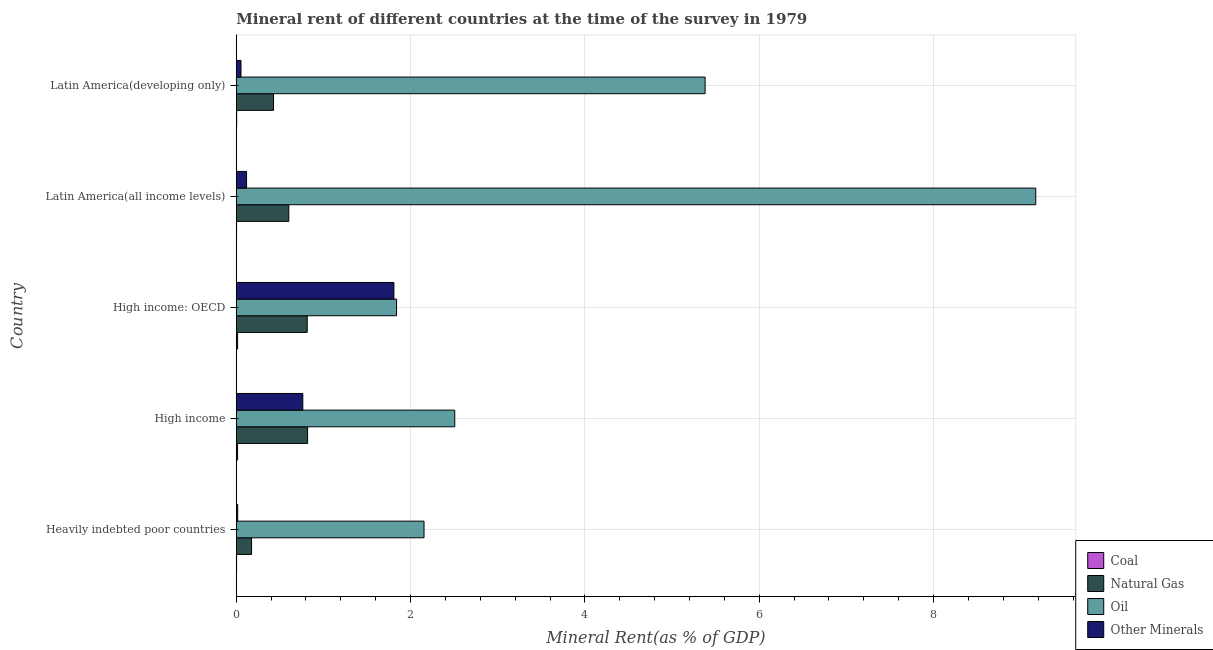How many bars are there on the 3rd tick from the top?
Give a very brief answer. 4. What is the label of the 5th group of bars from the top?
Ensure brevity in your answer.  Heavily indebted poor countries. In how many cases, is the number of bars for a given country not equal to the number of legend labels?
Your response must be concise. 0. What is the  rent of other minerals in Latin America(all income levels)?
Give a very brief answer. 0.12. Across all countries, what is the maximum oil rent?
Provide a short and direct response. 9.17. Across all countries, what is the minimum  rent of other minerals?
Your response must be concise. 0.02. In which country was the  rent of other minerals maximum?
Provide a succinct answer. High income: OECD. In which country was the natural gas rent minimum?
Your answer should be compact. Heavily indebted poor countries. What is the total natural gas rent in the graph?
Keep it short and to the point. 2.84. What is the difference between the natural gas rent in High income and that in Latin America(developing only)?
Ensure brevity in your answer.  0.39. What is the difference between the natural gas rent in High income and the  rent of other minerals in Heavily indebted poor countries?
Your response must be concise. 0.8. What is the average  rent of other minerals per country?
Your answer should be compact. 0.55. What is the difference between the natural gas rent and oil rent in Latin America(all income levels)?
Offer a terse response. -8.57. What is the ratio of the natural gas rent in Heavily indebted poor countries to that in Latin America(all income levels)?
Ensure brevity in your answer.  0.29. What is the difference between the highest and the second highest coal rent?
Make the answer very short. 0. What is the difference between the highest and the lowest natural gas rent?
Make the answer very short. 0.64. Is the sum of the  rent of other minerals in Latin America(all income levels) and Latin America(developing only) greater than the maximum oil rent across all countries?
Your answer should be very brief. No. Is it the case that in every country, the sum of the coal rent and  rent of other minerals is greater than the sum of natural gas rent and oil rent?
Ensure brevity in your answer.  No. What does the 2nd bar from the top in Latin America(all income levels) represents?
Provide a succinct answer. Oil. What does the 2nd bar from the bottom in Heavily indebted poor countries represents?
Your answer should be very brief. Natural Gas. Are all the bars in the graph horizontal?
Provide a short and direct response. Yes. How many countries are there in the graph?
Give a very brief answer. 5. What is the difference between two consecutive major ticks on the X-axis?
Your response must be concise. 2. Are the values on the major ticks of X-axis written in scientific E-notation?
Your answer should be compact. No. Does the graph contain grids?
Offer a very short reply. Yes. Where does the legend appear in the graph?
Provide a short and direct response. Bottom right. What is the title of the graph?
Your response must be concise. Mineral rent of different countries at the time of the survey in 1979. Does "Grants and Revenue" appear as one of the legend labels in the graph?
Keep it short and to the point. No. What is the label or title of the X-axis?
Ensure brevity in your answer.  Mineral Rent(as % of GDP). What is the label or title of the Y-axis?
Your answer should be very brief. Country. What is the Mineral Rent(as % of GDP) in Coal in Heavily indebted poor countries?
Provide a short and direct response. 0. What is the Mineral Rent(as % of GDP) in Natural Gas in Heavily indebted poor countries?
Make the answer very short. 0.18. What is the Mineral Rent(as % of GDP) in Oil in Heavily indebted poor countries?
Offer a terse response. 2.15. What is the Mineral Rent(as % of GDP) in Other Minerals in Heavily indebted poor countries?
Give a very brief answer. 0.02. What is the Mineral Rent(as % of GDP) of Coal in High income?
Ensure brevity in your answer.  0.02. What is the Mineral Rent(as % of GDP) in Natural Gas in High income?
Provide a short and direct response. 0.82. What is the Mineral Rent(as % of GDP) of Oil in High income?
Offer a terse response. 2.51. What is the Mineral Rent(as % of GDP) of Other Minerals in High income?
Provide a short and direct response. 0.76. What is the Mineral Rent(as % of GDP) in Coal in High income: OECD?
Give a very brief answer. 0.02. What is the Mineral Rent(as % of GDP) in Natural Gas in High income: OECD?
Offer a very short reply. 0.81. What is the Mineral Rent(as % of GDP) in Oil in High income: OECD?
Keep it short and to the point. 1.84. What is the Mineral Rent(as % of GDP) of Other Minerals in High income: OECD?
Provide a succinct answer. 1.81. What is the Mineral Rent(as % of GDP) in Coal in Latin America(all income levels)?
Offer a terse response. 0. What is the Mineral Rent(as % of GDP) in Natural Gas in Latin America(all income levels)?
Make the answer very short. 0.6. What is the Mineral Rent(as % of GDP) of Oil in Latin America(all income levels)?
Keep it short and to the point. 9.17. What is the Mineral Rent(as % of GDP) of Other Minerals in Latin America(all income levels)?
Make the answer very short. 0.12. What is the Mineral Rent(as % of GDP) of Coal in Latin America(developing only)?
Provide a short and direct response. 0. What is the Mineral Rent(as % of GDP) in Natural Gas in Latin America(developing only)?
Give a very brief answer. 0.43. What is the Mineral Rent(as % of GDP) in Oil in Latin America(developing only)?
Your response must be concise. 5.38. What is the Mineral Rent(as % of GDP) of Other Minerals in Latin America(developing only)?
Make the answer very short. 0.05. Across all countries, what is the maximum Mineral Rent(as % of GDP) of Coal?
Your response must be concise. 0.02. Across all countries, what is the maximum Mineral Rent(as % of GDP) of Natural Gas?
Provide a succinct answer. 0.82. Across all countries, what is the maximum Mineral Rent(as % of GDP) of Oil?
Ensure brevity in your answer.  9.17. Across all countries, what is the maximum Mineral Rent(as % of GDP) of Other Minerals?
Your answer should be compact. 1.81. Across all countries, what is the minimum Mineral Rent(as % of GDP) of Coal?
Ensure brevity in your answer.  0. Across all countries, what is the minimum Mineral Rent(as % of GDP) in Natural Gas?
Your response must be concise. 0.18. Across all countries, what is the minimum Mineral Rent(as % of GDP) in Oil?
Make the answer very short. 1.84. Across all countries, what is the minimum Mineral Rent(as % of GDP) in Other Minerals?
Ensure brevity in your answer.  0.02. What is the total Mineral Rent(as % of GDP) in Coal in the graph?
Your response must be concise. 0.04. What is the total Mineral Rent(as % of GDP) of Natural Gas in the graph?
Provide a short and direct response. 2.84. What is the total Mineral Rent(as % of GDP) in Oil in the graph?
Offer a very short reply. 21.05. What is the total Mineral Rent(as % of GDP) in Other Minerals in the graph?
Offer a very short reply. 2.76. What is the difference between the Mineral Rent(as % of GDP) in Coal in Heavily indebted poor countries and that in High income?
Your answer should be very brief. -0.01. What is the difference between the Mineral Rent(as % of GDP) in Natural Gas in Heavily indebted poor countries and that in High income?
Your response must be concise. -0.64. What is the difference between the Mineral Rent(as % of GDP) in Oil in Heavily indebted poor countries and that in High income?
Keep it short and to the point. -0.35. What is the difference between the Mineral Rent(as % of GDP) in Other Minerals in Heavily indebted poor countries and that in High income?
Your answer should be compact. -0.75. What is the difference between the Mineral Rent(as % of GDP) in Coal in Heavily indebted poor countries and that in High income: OECD?
Keep it short and to the point. -0.01. What is the difference between the Mineral Rent(as % of GDP) in Natural Gas in Heavily indebted poor countries and that in High income: OECD?
Offer a very short reply. -0.64. What is the difference between the Mineral Rent(as % of GDP) of Oil in Heavily indebted poor countries and that in High income: OECD?
Give a very brief answer. 0.31. What is the difference between the Mineral Rent(as % of GDP) in Other Minerals in Heavily indebted poor countries and that in High income: OECD?
Keep it short and to the point. -1.79. What is the difference between the Mineral Rent(as % of GDP) in Coal in Heavily indebted poor countries and that in Latin America(all income levels)?
Your answer should be very brief. 0. What is the difference between the Mineral Rent(as % of GDP) in Natural Gas in Heavily indebted poor countries and that in Latin America(all income levels)?
Your answer should be compact. -0.43. What is the difference between the Mineral Rent(as % of GDP) of Oil in Heavily indebted poor countries and that in Latin America(all income levels)?
Keep it short and to the point. -7.02. What is the difference between the Mineral Rent(as % of GDP) of Other Minerals in Heavily indebted poor countries and that in Latin America(all income levels)?
Provide a succinct answer. -0.1. What is the difference between the Mineral Rent(as % of GDP) in Coal in Heavily indebted poor countries and that in Latin America(developing only)?
Provide a succinct answer. -0. What is the difference between the Mineral Rent(as % of GDP) in Natural Gas in Heavily indebted poor countries and that in Latin America(developing only)?
Your response must be concise. -0.25. What is the difference between the Mineral Rent(as % of GDP) of Oil in Heavily indebted poor countries and that in Latin America(developing only)?
Ensure brevity in your answer.  -3.22. What is the difference between the Mineral Rent(as % of GDP) in Other Minerals in Heavily indebted poor countries and that in Latin America(developing only)?
Keep it short and to the point. -0.04. What is the difference between the Mineral Rent(as % of GDP) in Coal in High income and that in High income: OECD?
Provide a short and direct response. -0. What is the difference between the Mineral Rent(as % of GDP) of Natural Gas in High income and that in High income: OECD?
Your response must be concise. 0. What is the difference between the Mineral Rent(as % of GDP) in Oil in High income and that in High income: OECD?
Make the answer very short. 0.67. What is the difference between the Mineral Rent(as % of GDP) of Other Minerals in High income and that in High income: OECD?
Provide a succinct answer. -1.05. What is the difference between the Mineral Rent(as % of GDP) of Coal in High income and that in Latin America(all income levels)?
Give a very brief answer. 0.01. What is the difference between the Mineral Rent(as % of GDP) of Natural Gas in High income and that in Latin America(all income levels)?
Keep it short and to the point. 0.22. What is the difference between the Mineral Rent(as % of GDP) of Oil in High income and that in Latin America(all income levels)?
Your answer should be very brief. -6.67. What is the difference between the Mineral Rent(as % of GDP) of Other Minerals in High income and that in Latin America(all income levels)?
Provide a short and direct response. 0.65. What is the difference between the Mineral Rent(as % of GDP) of Coal in High income and that in Latin America(developing only)?
Offer a terse response. 0.01. What is the difference between the Mineral Rent(as % of GDP) of Natural Gas in High income and that in Latin America(developing only)?
Your response must be concise. 0.39. What is the difference between the Mineral Rent(as % of GDP) in Oil in High income and that in Latin America(developing only)?
Your answer should be very brief. -2.87. What is the difference between the Mineral Rent(as % of GDP) in Other Minerals in High income and that in Latin America(developing only)?
Provide a short and direct response. 0.71. What is the difference between the Mineral Rent(as % of GDP) in Coal in High income: OECD and that in Latin America(all income levels)?
Offer a very short reply. 0.01. What is the difference between the Mineral Rent(as % of GDP) of Natural Gas in High income: OECD and that in Latin America(all income levels)?
Make the answer very short. 0.21. What is the difference between the Mineral Rent(as % of GDP) of Oil in High income: OECD and that in Latin America(all income levels)?
Your response must be concise. -7.33. What is the difference between the Mineral Rent(as % of GDP) in Other Minerals in High income: OECD and that in Latin America(all income levels)?
Your answer should be compact. 1.69. What is the difference between the Mineral Rent(as % of GDP) in Coal in High income: OECD and that in Latin America(developing only)?
Ensure brevity in your answer.  0.01. What is the difference between the Mineral Rent(as % of GDP) in Natural Gas in High income: OECD and that in Latin America(developing only)?
Make the answer very short. 0.39. What is the difference between the Mineral Rent(as % of GDP) in Oil in High income: OECD and that in Latin America(developing only)?
Your answer should be very brief. -3.54. What is the difference between the Mineral Rent(as % of GDP) in Other Minerals in High income: OECD and that in Latin America(developing only)?
Give a very brief answer. 1.75. What is the difference between the Mineral Rent(as % of GDP) in Coal in Latin America(all income levels) and that in Latin America(developing only)?
Keep it short and to the point. -0. What is the difference between the Mineral Rent(as % of GDP) of Natural Gas in Latin America(all income levels) and that in Latin America(developing only)?
Ensure brevity in your answer.  0.18. What is the difference between the Mineral Rent(as % of GDP) of Oil in Latin America(all income levels) and that in Latin America(developing only)?
Offer a terse response. 3.79. What is the difference between the Mineral Rent(as % of GDP) of Other Minerals in Latin America(all income levels) and that in Latin America(developing only)?
Keep it short and to the point. 0.06. What is the difference between the Mineral Rent(as % of GDP) in Coal in Heavily indebted poor countries and the Mineral Rent(as % of GDP) in Natural Gas in High income?
Provide a short and direct response. -0.81. What is the difference between the Mineral Rent(as % of GDP) in Coal in Heavily indebted poor countries and the Mineral Rent(as % of GDP) in Oil in High income?
Your answer should be very brief. -2.5. What is the difference between the Mineral Rent(as % of GDP) in Coal in Heavily indebted poor countries and the Mineral Rent(as % of GDP) in Other Minerals in High income?
Provide a short and direct response. -0.76. What is the difference between the Mineral Rent(as % of GDP) of Natural Gas in Heavily indebted poor countries and the Mineral Rent(as % of GDP) of Oil in High income?
Ensure brevity in your answer.  -2.33. What is the difference between the Mineral Rent(as % of GDP) in Natural Gas in Heavily indebted poor countries and the Mineral Rent(as % of GDP) in Other Minerals in High income?
Offer a very short reply. -0.59. What is the difference between the Mineral Rent(as % of GDP) in Oil in Heavily indebted poor countries and the Mineral Rent(as % of GDP) in Other Minerals in High income?
Ensure brevity in your answer.  1.39. What is the difference between the Mineral Rent(as % of GDP) of Coal in Heavily indebted poor countries and the Mineral Rent(as % of GDP) of Natural Gas in High income: OECD?
Give a very brief answer. -0.81. What is the difference between the Mineral Rent(as % of GDP) in Coal in Heavily indebted poor countries and the Mineral Rent(as % of GDP) in Oil in High income: OECD?
Make the answer very short. -1.84. What is the difference between the Mineral Rent(as % of GDP) in Coal in Heavily indebted poor countries and the Mineral Rent(as % of GDP) in Other Minerals in High income: OECD?
Offer a very short reply. -1.81. What is the difference between the Mineral Rent(as % of GDP) of Natural Gas in Heavily indebted poor countries and the Mineral Rent(as % of GDP) of Oil in High income: OECD?
Your answer should be very brief. -1.66. What is the difference between the Mineral Rent(as % of GDP) in Natural Gas in Heavily indebted poor countries and the Mineral Rent(as % of GDP) in Other Minerals in High income: OECD?
Provide a short and direct response. -1.63. What is the difference between the Mineral Rent(as % of GDP) of Oil in Heavily indebted poor countries and the Mineral Rent(as % of GDP) of Other Minerals in High income: OECD?
Offer a very short reply. 0.35. What is the difference between the Mineral Rent(as % of GDP) of Coal in Heavily indebted poor countries and the Mineral Rent(as % of GDP) of Natural Gas in Latin America(all income levels)?
Offer a terse response. -0.6. What is the difference between the Mineral Rent(as % of GDP) of Coal in Heavily indebted poor countries and the Mineral Rent(as % of GDP) of Oil in Latin America(all income levels)?
Make the answer very short. -9.17. What is the difference between the Mineral Rent(as % of GDP) of Coal in Heavily indebted poor countries and the Mineral Rent(as % of GDP) of Other Minerals in Latin America(all income levels)?
Ensure brevity in your answer.  -0.11. What is the difference between the Mineral Rent(as % of GDP) of Natural Gas in Heavily indebted poor countries and the Mineral Rent(as % of GDP) of Oil in Latin America(all income levels)?
Ensure brevity in your answer.  -9. What is the difference between the Mineral Rent(as % of GDP) in Natural Gas in Heavily indebted poor countries and the Mineral Rent(as % of GDP) in Other Minerals in Latin America(all income levels)?
Offer a very short reply. 0.06. What is the difference between the Mineral Rent(as % of GDP) in Oil in Heavily indebted poor countries and the Mineral Rent(as % of GDP) in Other Minerals in Latin America(all income levels)?
Your answer should be compact. 2.04. What is the difference between the Mineral Rent(as % of GDP) of Coal in Heavily indebted poor countries and the Mineral Rent(as % of GDP) of Natural Gas in Latin America(developing only)?
Ensure brevity in your answer.  -0.42. What is the difference between the Mineral Rent(as % of GDP) of Coal in Heavily indebted poor countries and the Mineral Rent(as % of GDP) of Oil in Latin America(developing only)?
Give a very brief answer. -5.38. What is the difference between the Mineral Rent(as % of GDP) of Coal in Heavily indebted poor countries and the Mineral Rent(as % of GDP) of Other Minerals in Latin America(developing only)?
Provide a short and direct response. -0.05. What is the difference between the Mineral Rent(as % of GDP) of Natural Gas in Heavily indebted poor countries and the Mineral Rent(as % of GDP) of Oil in Latin America(developing only)?
Provide a short and direct response. -5.2. What is the difference between the Mineral Rent(as % of GDP) in Natural Gas in Heavily indebted poor countries and the Mineral Rent(as % of GDP) in Other Minerals in Latin America(developing only)?
Offer a terse response. 0.12. What is the difference between the Mineral Rent(as % of GDP) in Coal in High income and the Mineral Rent(as % of GDP) in Natural Gas in High income: OECD?
Provide a succinct answer. -0.8. What is the difference between the Mineral Rent(as % of GDP) of Coal in High income and the Mineral Rent(as % of GDP) of Oil in High income: OECD?
Provide a short and direct response. -1.82. What is the difference between the Mineral Rent(as % of GDP) of Coal in High income and the Mineral Rent(as % of GDP) of Other Minerals in High income: OECD?
Provide a succinct answer. -1.79. What is the difference between the Mineral Rent(as % of GDP) in Natural Gas in High income and the Mineral Rent(as % of GDP) in Oil in High income: OECD?
Offer a very short reply. -1.02. What is the difference between the Mineral Rent(as % of GDP) in Natural Gas in High income and the Mineral Rent(as % of GDP) in Other Minerals in High income: OECD?
Provide a succinct answer. -0.99. What is the difference between the Mineral Rent(as % of GDP) of Oil in High income and the Mineral Rent(as % of GDP) of Other Minerals in High income: OECD?
Make the answer very short. 0.7. What is the difference between the Mineral Rent(as % of GDP) in Coal in High income and the Mineral Rent(as % of GDP) in Natural Gas in Latin America(all income levels)?
Make the answer very short. -0.59. What is the difference between the Mineral Rent(as % of GDP) in Coal in High income and the Mineral Rent(as % of GDP) in Oil in Latin America(all income levels)?
Keep it short and to the point. -9.16. What is the difference between the Mineral Rent(as % of GDP) in Coal in High income and the Mineral Rent(as % of GDP) in Other Minerals in Latin America(all income levels)?
Offer a very short reply. -0.1. What is the difference between the Mineral Rent(as % of GDP) of Natural Gas in High income and the Mineral Rent(as % of GDP) of Oil in Latin America(all income levels)?
Keep it short and to the point. -8.35. What is the difference between the Mineral Rent(as % of GDP) of Natural Gas in High income and the Mineral Rent(as % of GDP) of Other Minerals in Latin America(all income levels)?
Offer a very short reply. 0.7. What is the difference between the Mineral Rent(as % of GDP) of Oil in High income and the Mineral Rent(as % of GDP) of Other Minerals in Latin America(all income levels)?
Ensure brevity in your answer.  2.39. What is the difference between the Mineral Rent(as % of GDP) of Coal in High income and the Mineral Rent(as % of GDP) of Natural Gas in Latin America(developing only)?
Provide a succinct answer. -0.41. What is the difference between the Mineral Rent(as % of GDP) in Coal in High income and the Mineral Rent(as % of GDP) in Oil in Latin America(developing only)?
Give a very brief answer. -5.36. What is the difference between the Mineral Rent(as % of GDP) of Coal in High income and the Mineral Rent(as % of GDP) of Other Minerals in Latin America(developing only)?
Provide a short and direct response. -0.04. What is the difference between the Mineral Rent(as % of GDP) in Natural Gas in High income and the Mineral Rent(as % of GDP) in Oil in Latin America(developing only)?
Offer a very short reply. -4.56. What is the difference between the Mineral Rent(as % of GDP) of Natural Gas in High income and the Mineral Rent(as % of GDP) of Other Minerals in Latin America(developing only)?
Your answer should be very brief. 0.76. What is the difference between the Mineral Rent(as % of GDP) of Oil in High income and the Mineral Rent(as % of GDP) of Other Minerals in Latin America(developing only)?
Your response must be concise. 2.45. What is the difference between the Mineral Rent(as % of GDP) in Coal in High income: OECD and the Mineral Rent(as % of GDP) in Natural Gas in Latin America(all income levels)?
Your answer should be very brief. -0.59. What is the difference between the Mineral Rent(as % of GDP) in Coal in High income: OECD and the Mineral Rent(as % of GDP) in Oil in Latin America(all income levels)?
Provide a succinct answer. -9.16. What is the difference between the Mineral Rent(as % of GDP) of Coal in High income: OECD and the Mineral Rent(as % of GDP) of Other Minerals in Latin America(all income levels)?
Offer a terse response. -0.1. What is the difference between the Mineral Rent(as % of GDP) in Natural Gas in High income: OECD and the Mineral Rent(as % of GDP) in Oil in Latin America(all income levels)?
Provide a short and direct response. -8.36. What is the difference between the Mineral Rent(as % of GDP) of Natural Gas in High income: OECD and the Mineral Rent(as % of GDP) of Other Minerals in Latin America(all income levels)?
Your response must be concise. 0.7. What is the difference between the Mineral Rent(as % of GDP) of Oil in High income: OECD and the Mineral Rent(as % of GDP) of Other Minerals in Latin America(all income levels)?
Your answer should be very brief. 1.72. What is the difference between the Mineral Rent(as % of GDP) of Coal in High income: OECD and the Mineral Rent(as % of GDP) of Natural Gas in Latin America(developing only)?
Give a very brief answer. -0.41. What is the difference between the Mineral Rent(as % of GDP) in Coal in High income: OECD and the Mineral Rent(as % of GDP) in Oil in Latin America(developing only)?
Your response must be concise. -5.36. What is the difference between the Mineral Rent(as % of GDP) of Coal in High income: OECD and the Mineral Rent(as % of GDP) of Other Minerals in Latin America(developing only)?
Your response must be concise. -0.04. What is the difference between the Mineral Rent(as % of GDP) of Natural Gas in High income: OECD and the Mineral Rent(as % of GDP) of Oil in Latin America(developing only)?
Your answer should be very brief. -4.56. What is the difference between the Mineral Rent(as % of GDP) in Natural Gas in High income: OECD and the Mineral Rent(as % of GDP) in Other Minerals in Latin America(developing only)?
Give a very brief answer. 0.76. What is the difference between the Mineral Rent(as % of GDP) of Oil in High income: OECD and the Mineral Rent(as % of GDP) of Other Minerals in Latin America(developing only)?
Provide a short and direct response. 1.79. What is the difference between the Mineral Rent(as % of GDP) of Coal in Latin America(all income levels) and the Mineral Rent(as % of GDP) of Natural Gas in Latin America(developing only)?
Your response must be concise. -0.42. What is the difference between the Mineral Rent(as % of GDP) of Coal in Latin America(all income levels) and the Mineral Rent(as % of GDP) of Oil in Latin America(developing only)?
Provide a short and direct response. -5.38. What is the difference between the Mineral Rent(as % of GDP) in Coal in Latin America(all income levels) and the Mineral Rent(as % of GDP) in Other Minerals in Latin America(developing only)?
Offer a terse response. -0.05. What is the difference between the Mineral Rent(as % of GDP) of Natural Gas in Latin America(all income levels) and the Mineral Rent(as % of GDP) of Oil in Latin America(developing only)?
Provide a succinct answer. -4.78. What is the difference between the Mineral Rent(as % of GDP) in Natural Gas in Latin America(all income levels) and the Mineral Rent(as % of GDP) in Other Minerals in Latin America(developing only)?
Provide a short and direct response. 0.55. What is the difference between the Mineral Rent(as % of GDP) of Oil in Latin America(all income levels) and the Mineral Rent(as % of GDP) of Other Minerals in Latin America(developing only)?
Provide a short and direct response. 9.12. What is the average Mineral Rent(as % of GDP) in Coal per country?
Provide a short and direct response. 0.01. What is the average Mineral Rent(as % of GDP) in Natural Gas per country?
Your answer should be very brief. 0.57. What is the average Mineral Rent(as % of GDP) in Oil per country?
Provide a short and direct response. 4.21. What is the average Mineral Rent(as % of GDP) of Other Minerals per country?
Keep it short and to the point. 0.55. What is the difference between the Mineral Rent(as % of GDP) in Coal and Mineral Rent(as % of GDP) in Natural Gas in Heavily indebted poor countries?
Give a very brief answer. -0.17. What is the difference between the Mineral Rent(as % of GDP) of Coal and Mineral Rent(as % of GDP) of Oil in Heavily indebted poor countries?
Offer a very short reply. -2.15. What is the difference between the Mineral Rent(as % of GDP) of Coal and Mineral Rent(as % of GDP) of Other Minerals in Heavily indebted poor countries?
Ensure brevity in your answer.  -0.01. What is the difference between the Mineral Rent(as % of GDP) of Natural Gas and Mineral Rent(as % of GDP) of Oil in Heavily indebted poor countries?
Offer a terse response. -1.98. What is the difference between the Mineral Rent(as % of GDP) of Natural Gas and Mineral Rent(as % of GDP) of Other Minerals in Heavily indebted poor countries?
Make the answer very short. 0.16. What is the difference between the Mineral Rent(as % of GDP) of Oil and Mineral Rent(as % of GDP) of Other Minerals in Heavily indebted poor countries?
Make the answer very short. 2.14. What is the difference between the Mineral Rent(as % of GDP) in Coal and Mineral Rent(as % of GDP) in Natural Gas in High income?
Your answer should be very brief. -0.8. What is the difference between the Mineral Rent(as % of GDP) of Coal and Mineral Rent(as % of GDP) of Oil in High income?
Give a very brief answer. -2.49. What is the difference between the Mineral Rent(as % of GDP) of Coal and Mineral Rent(as % of GDP) of Other Minerals in High income?
Your response must be concise. -0.75. What is the difference between the Mineral Rent(as % of GDP) of Natural Gas and Mineral Rent(as % of GDP) of Oil in High income?
Give a very brief answer. -1.69. What is the difference between the Mineral Rent(as % of GDP) of Natural Gas and Mineral Rent(as % of GDP) of Other Minerals in High income?
Give a very brief answer. 0.05. What is the difference between the Mineral Rent(as % of GDP) in Oil and Mineral Rent(as % of GDP) in Other Minerals in High income?
Your response must be concise. 1.74. What is the difference between the Mineral Rent(as % of GDP) of Coal and Mineral Rent(as % of GDP) of Natural Gas in High income: OECD?
Keep it short and to the point. -0.8. What is the difference between the Mineral Rent(as % of GDP) in Coal and Mineral Rent(as % of GDP) in Oil in High income: OECD?
Offer a very short reply. -1.82. What is the difference between the Mineral Rent(as % of GDP) in Coal and Mineral Rent(as % of GDP) in Other Minerals in High income: OECD?
Your answer should be very brief. -1.79. What is the difference between the Mineral Rent(as % of GDP) of Natural Gas and Mineral Rent(as % of GDP) of Oil in High income: OECD?
Offer a terse response. -1.03. What is the difference between the Mineral Rent(as % of GDP) of Natural Gas and Mineral Rent(as % of GDP) of Other Minerals in High income: OECD?
Make the answer very short. -0.99. What is the difference between the Mineral Rent(as % of GDP) in Oil and Mineral Rent(as % of GDP) in Other Minerals in High income: OECD?
Make the answer very short. 0.03. What is the difference between the Mineral Rent(as % of GDP) in Coal and Mineral Rent(as % of GDP) in Natural Gas in Latin America(all income levels)?
Ensure brevity in your answer.  -0.6. What is the difference between the Mineral Rent(as % of GDP) of Coal and Mineral Rent(as % of GDP) of Oil in Latin America(all income levels)?
Offer a very short reply. -9.17. What is the difference between the Mineral Rent(as % of GDP) of Coal and Mineral Rent(as % of GDP) of Other Minerals in Latin America(all income levels)?
Your answer should be compact. -0.11. What is the difference between the Mineral Rent(as % of GDP) of Natural Gas and Mineral Rent(as % of GDP) of Oil in Latin America(all income levels)?
Your response must be concise. -8.57. What is the difference between the Mineral Rent(as % of GDP) in Natural Gas and Mineral Rent(as % of GDP) in Other Minerals in Latin America(all income levels)?
Provide a succinct answer. 0.48. What is the difference between the Mineral Rent(as % of GDP) of Oil and Mineral Rent(as % of GDP) of Other Minerals in Latin America(all income levels)?
Make the answer very short. 9.05. What is the difference between the Mineral Rent(as % of GDP) of Coal and Mineral Rent(as % of GDP) of Natural Gas in Latin America(developing only)?
Give a very brief answer. -0.42. What is the difference between the Mineral Rent(as % of GDP) of Coal and Mineral Rent(as % of GDP) of Oil in Latin America(developing only)?
Provide a short and direct response. -5.37. What is the difference between the Mineral Rent(as % of GDP) of Coal and Mineral Rent(as % of GDP) of Other Minerals in Latin America(developing only)?
Your answer should be compact. -0.05. What is the difference between the Mineral Rent(as % of GDP) of Natural Gas and Mineral Rent(as % of GDP) of Oil in Latin America(developing only)?
Offer a very short reply. -4.95. What is the difference between the Mineral Rent(as % of GDP) in Natural Gas and Mineral Rent(as % of GDP) in Other Minerals in Latin America(developing only)?
Provide a short and direct response. 0.37. What is the difference between the Mineral Rent(as % of GDP) of Oil and Mineral Rent(as % of GDP) of Other Minerals in Latin America(developing only)?
Keep it short and to the point. 5.32. What is the ratio of the Mineral Rent(as % of GDP) of Coal in Heavily indebted poor countries to that in High income?
Give a very brief answer. 0.24. What is the ratio of the Mineral Rent(as % of GDP) of Natural Gas in Heavily indebted poor countries to that in High income?
Provide a succinct answer. 0.21. What is the ratio of the Mineral Rent(as % of GDP) in Oil in Heavily indebted poor countries to that in High income?
Your response must be concise. 0.86. What is the ratio of the Mineral Rent(as % of GDP) in Other Minerals in Heavily indebted poor countries to that in High income?
Give a very brief answer. 0.02. What is the ratio of the Mineral Rent(as % of GDP) of Coal in Heavily indebted poor countries to that in High income: OECD?
Provide a succinct answer. 0.24. What is the ratio of the Mineral Rent(as % of GDP) in Natural Gas in Heavily indebted poor countries to that in High income: OECD?
Your response must be concise. 0.22. What is the ratio of the Mineral Rent(as % of GDP) of Oil in Heavily indebted poor countries to that in High income: OECD?
Make the answer very short. 1.17. What is the ratio of the Mineral Rent(as % of GDP) in Other Minerals in Heavily indebted poor countries to that in High income: OECD?
Provide a succinct answer. 0.01. What is the ratio of the Mineral Rent(as % of GDP) in Coal in Heavily indebted poor countries to that in Latin America(all income levels)?
Offer a very short reply. 1.04. What is the ratio of the Mineral Rent(as % of GDP) of Natural Gas in Heavily indebted poor countries to that in Latin America(all income levels)?
Keep it short and to the point. 0.29. What is the ratio of the Mineral Rent(as % of GDP) in Oil in Heavily indebted poor countries to that in Latin America(all income levels)?
Your answer should be compact. 0.23. What is the ratio of the Mineral Rent(as % of GDP) of Other Minerals in Heavily indebted poor countries to that in Latin America(all income levels)?
Give a very brief answer. 0.14. What is the ratio of the Mineral Rent(as % of GDP) of Coal in Heavily indebted poor countries to that in Latin America(developing only)?
Offer a very short reply. 0.77. What is the ratio of the Mineral Rent(as % of GDP) of Natural Gas in Heavily indebted poor countries to that in Latin America(developing only)?
Make the answer very short. 0.41. What is the ratio of the Mineral Rent(as % of GDP) of Oil in Heavily indebted poor countries to that in Latin America(developing only)?
Provide a succinct answer. 0.4. What is the ratio of the Mineral Rent(as % of GDP) of Other Minerals in Heavily indebted poor countries to that in Latin America(developing only)?
Offer a very short reply. 0.3. What is the ratio of the Mineral Rent(as % of GDP) in Coal in High income to that in High income: OECD?
Provide a succinct answer. 0.98. What is the ratio of the Mineral Rent(as % of GDP) of Natural Gas in High income to that in High income: OECD?
Give a very brief answer. 1.01. What is the ratio of the Mineral Rent(as % of GDP) in Oil in High income to that in High income: OECD?
Keep it short and to the point. 1.36. What is the ratio of the Mineral Rent(as % of GDP) in Other Minerals in High income to that in High income: OECD?
Ensure brevity in your answer.  0.42. What is the ratio of the Mineral Rent(as % of GDP) in Coal in High income to that in Latin America(all income levels)?
Give a very brief answer. 4.3. What is the ratio of the Mineral Rent(as % of GDP) of Natural Gas in High income to that in Latin America(all income levels)?
Offer a very short reply. 1.36. What is the ratio of the Mineral Rent(as % of GDP) of Oil in High income to that in Latin America(all income levels)?
Offer a terse response. 0.27. What is the ratio of the Mineral Rent(as % of GDP) of Other Minerals in High income to that in Latin America(all income levels)?
Your answer should be very brief. 6.46. What is the ratio of the Mineral Rent(as % of GDP) of Coal in High income to that in Latin America(developing only)?
Provide a short and direct response. 3.16. What is the ratio of the Mineral Rent(as % of GDP) in Natural Gas in High income to that in Latin America(developing only)?
Your answer should be very brief. 1.91. What is the ratio of the Mineral Rent(as % of GDP) in Oil in High income to that in Latin America(developing only)?
Provide a short and direct response. 0.47. What is the ratio of the Mineral Rent(as % of GDP) of Other Minerals in High income to that in Latin America(developing only)?
Your answer should be compact. 14.06. What is the ratio of the Mineral Rent(as % of GDP) in Coal in High income: OECD to that in Latin America(all income levels)?
Offer a terse response. 4.4. What is the ratio of the Mineral Rent(as % of GDP) in Natural Gas in High income: OECD to that in Latin America(all income levels)?
Your answer should be compact. 1.35. What is the ratio of the Mineral Rent(as % of GDP) in Oil in High income: OECD to that in Latin America(all income levels)?
Make the answer very short. 0.2. What is the ratio of the Mineral Rent(as % of GDP) of Other Minerals in High income: OECD to that in Latin America(all income levels)?
Ensure brevity in your answer.  15.29. What is the ratio of the Mineral Rent(as % of GDP) of Coal in High income: OECD to that in Latin America(developing only)?
Provide a short and direct response. 3.23. What is the ratio of the Mineral Rent(as % of GDP) in Natural Gas in High income: OECD to that in Latin America(developing only)?
Offer a very short reply. 1.9. What is the ratio of the Mineral Rent(as % of GDP) of Oil in High income: OECD to that in Latin America(developing only)?
Give a very brief answer. 0.34. What is the ratio of the Mineral Rent(as % of GDP) of Other Minerals in High income: OECD to that in Latin America(developing only)?
Your answer should be very brief. 33.31. What is the ratio of the Mineral Rent(as % of GDP) in Coal in Latin America(all income levels) to that in Latin America(developing only)?
Your answer should be compact. 0.73. What is the ratio of the Mineral Rent(as % of GDP) in Natural Gas in Latin America(all income levels) to that in Latin America(developing only)?
Offer a terse response. 1.41. What is the ratio of the Mineral Rent(as % of GDP) in Oil in Latin America(all income levels) to that in Latin America(developing only)?
Offer a very short reply. 1.71. What is the ratio of the Mineral Rent(as % of GDP) in Other Minerals in Latin America(all income levels) to that in Latin America(developing only)?
Ensure brevity in your answer.  2.18. What is the difference between the highest and the second highest Mineral Rent(as % of GDP) of Natural Gas?
Your answer should be very brief. 0. What is the difference between the highest and the second highest Mineral Rent(as % of GDP) in Oil?
Your answer should be compact. 3.79. What is the difference between the highest and the second highest Mineral Rent(as % of GDP) of Other Minerals?
Your answer should be very brief. 1.05. What is the difference between the highest and the lowest Mineral Rent(as % of GDP) of Coal?
Ensure brevity in your answer.  0.01. What is the difference between the highest and the lowest Mineral Rent(as % of GDP) in Natural Gas?
Offer a very short reply. 0.64. What is the difference between the highest and the lowest Mineral Rent(as % of GDP) in Oil?
Give a very brief answer. 7.33. What is the difference between the highest and the lowest Mineral Rent(as % of GDP) of Other Minerals?
Make the answer very short. 1.79. 